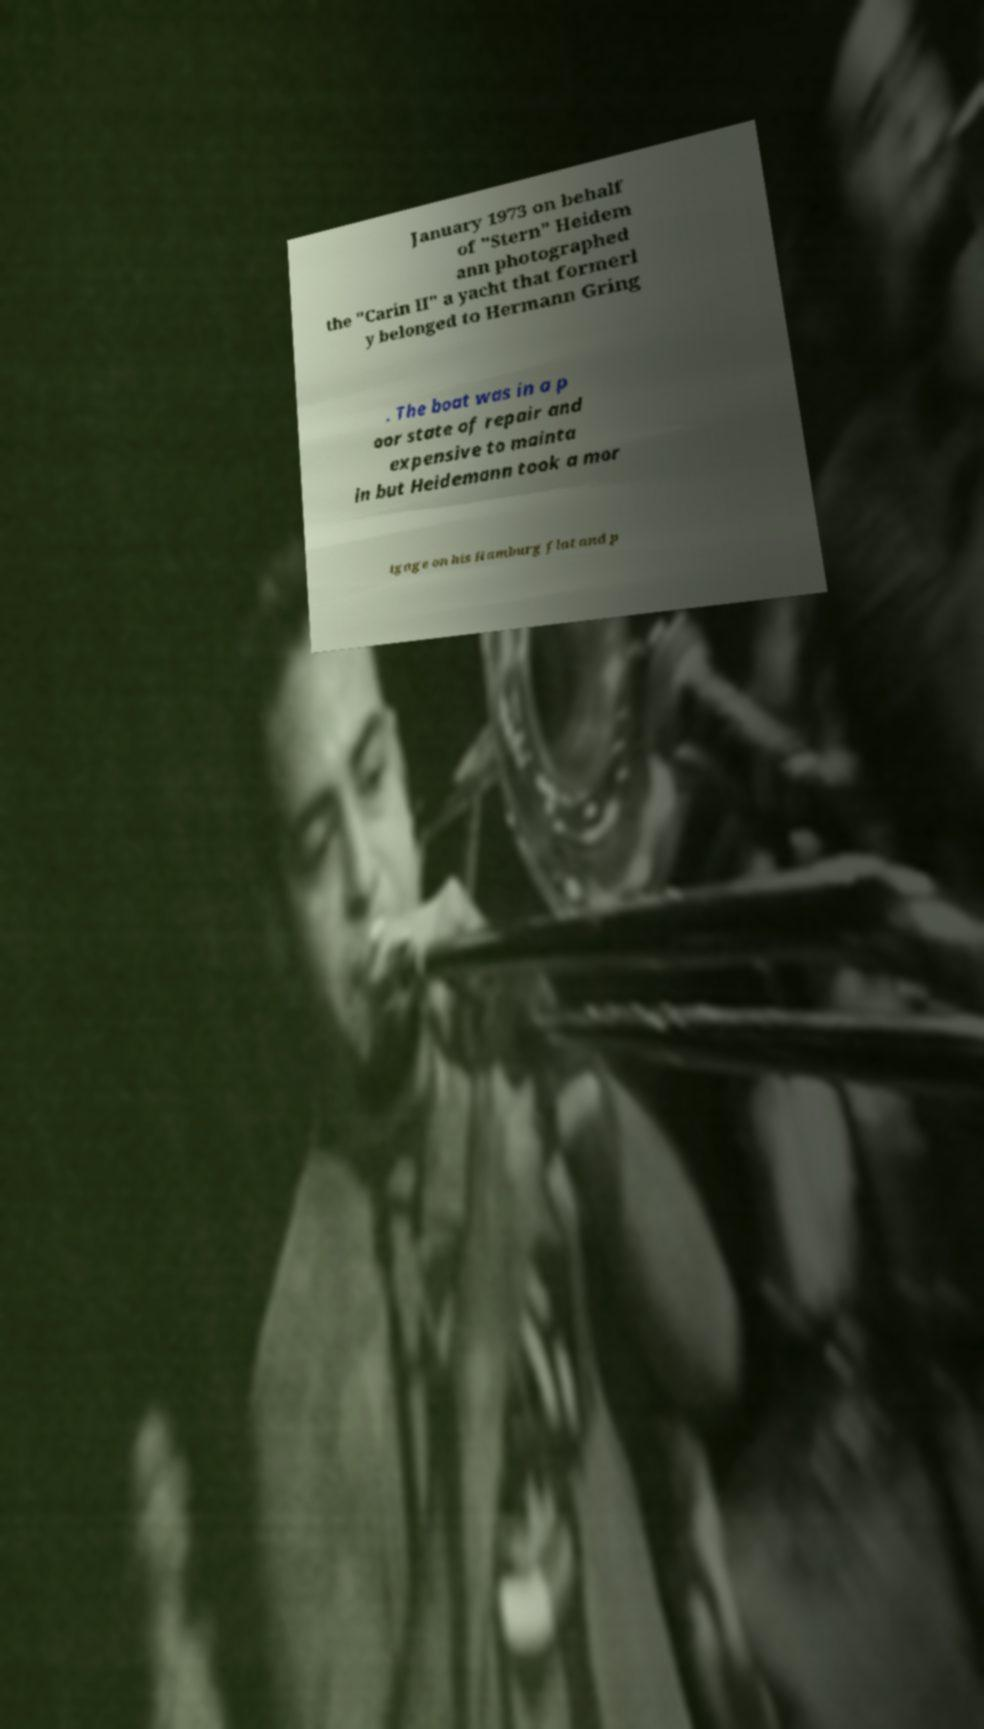For documentation purposes, I need the text within this image transcribed. Could you provide that? January 1973 on behalf of "Stern" Heidem ann photographed the "Carin II" a yacht that formerl y belonged to Hermann Gring . The boat was in a p oor state of repair and expensive to mainta in but Heidemann took a mor tgage on his Hamburg flat and p 